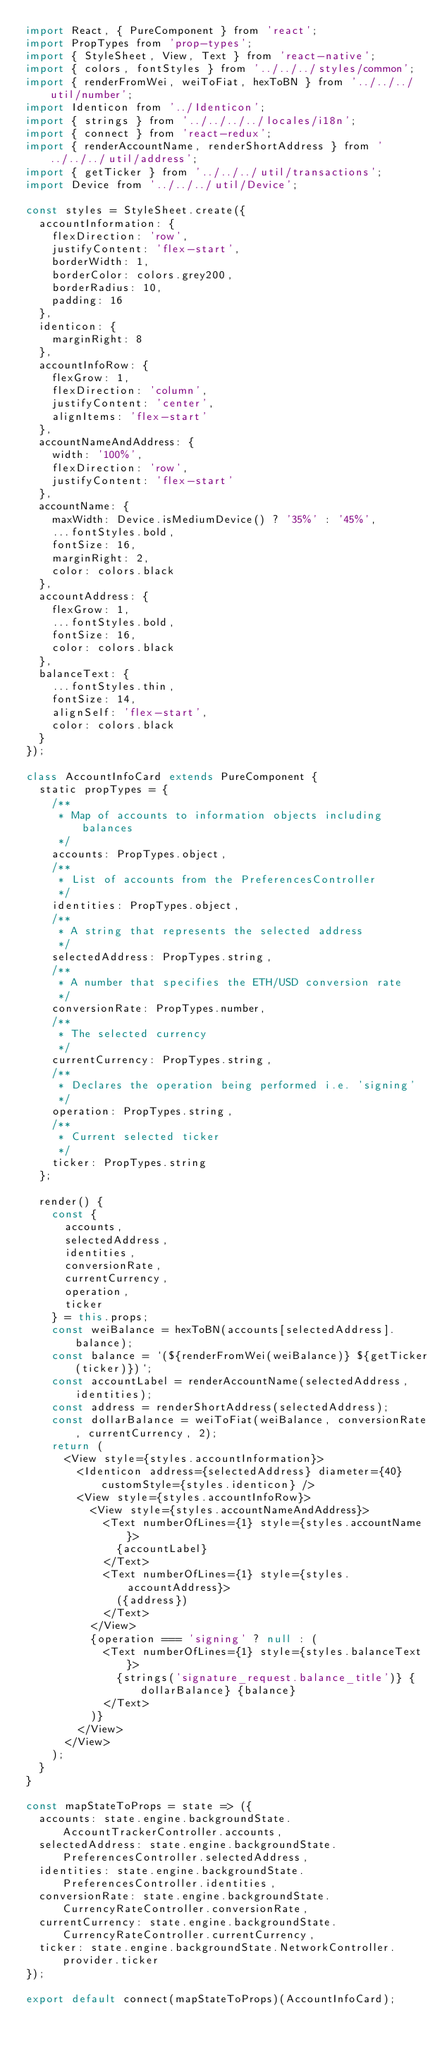<code> <loc_0><loc_0><loc_500><loc_500><_JavaScript_>import React, { PureComponent } from 'react';
import PropTypes from 'prop-types';
import { StyleSheet, View, Text } from 'react-native';
import { colors, fontStyles } from '../../../styles/common';
import { renderFromWei, weiToFiat, hexToBN } from '../../../util/number';
import Identicon from '../Identicon';
import { strings } from '../../../../locales/i18n';
import { connect } from 'react-redux';
import { renderAccountName, renderShortAddress } from '../../../util/address';
import { getTicker } from '../../../util/transactions';
import Device from '../../../util/Device';

const styles = StyleSheet.create({
	accountInformation: {
		flexDirection: 'row',
		justifyContent: 'flex-start',
		borderWidth: 1,
		borderColor: colors.grey200,
		borderRadius: 10,
		padding: 16
	},
	identicon: {
		marginRight: 8
	},
	accountInfoRow: {
		flexGrow: 1,
		flexDirection: 'column',
		justifyContent: 'center',
		alignItems: 'flex-start'
	},
	accountNameAndAddress: {
		width: '100%',
		flexDirection: 'row',
		justifyContent: 'flex-start'
	},
	accountName: {
		maxWidth: Device.isMediumDevice() ? '35%' : '45%',
		...fontStyles.bold,
		fontSize: 16,
		marginRight: 2,
		color: colors.black
	},
	accountAddress: {
		flexGrow: 1,
		...fontStyles.bold,
		fontSize: 16,
		color: colors.black
	},
	balanceText: {
		...fontStyles.thin,
		fontSize: 14,
		alignSelf: 'flex-start',
		color: colors.black
	}
});

class AccountInfoCard extends PureComponent {
	static propTypes = {
		/**
		 * Map of accounts to information objects including balances
		 */
		accounts: PropTypes.object,
		/**
		 * List of accounts from the PreferencesController
		 */
		identities: PropTypes.object,
		/**
		 * A string that represents the selected address
		 */
		selectedAddress: PropTypes.string,
		/**
		 * A number that specifies the ETH/USD conversion rate
		 */
		conversionRate: PropTypes.number,
		/**
		 * The selected currency
		 */
		currentCurrency: PropTypes.string,
		/**
		 * Declares the operation being performed i.e. 'signing'
		 */
		operation: PropTypes.string,
		/**
		 * Current selected ticker
		 */
		ticker: PropTypes.string
	};

	render() {
		const {
			accounts,
			selectedAddress,
			identities,
			conversionRate,
			currentCurrency,
			operation,
			ticker
		} = this.props;
		const weiBalance = hexToBN(accounts[selectedAddress].balance);
		const balance = `(${renderFromWei(weiBalance)} ${getTicker(ticker)})`;
		const accountLabel = renderAccountName(selectedAddress, identities);
		const address = renderShortAddress(selectedAddress);
		const dollarBalance = weiToFiat(weiBalance, conversionRate, currentCurrency, 2);
		return (
			<View style={styles.accountInformation}>
				<Identicon address={selectedAddress} diameter={40} customStyle={styles.identicon} />
				<View style={styles.accountInfoRow}>
					<View style={styles.accountNameAndAddress}>
						<Text numberOfLines={1} style={styles.accountName}>
							{accountLabel}
						</Text>
						<Text numberOfLines={1} style={styles.accountAddress}>
							({address})
						</Text>
					</View>
					{operation === 'signing' ? null : (
						<Text numberOfLines={1} style={styles.balanceText}>
							{strings('signature_request.balance_title')} {dollarBalance} {balance}
						</Text>
					)}
				</View>
			</View>
		);
	}
}

const mapStateToProps = state => ({
	accounts: state.engine.backgroundState.AccountTrackerController.accounts,
	selectedAddress: state.engine.backgroundState.PreferencesController.selectedAddress,
	identities: state.engine.backgroundState.PreferencesController.identities,
	conversionRate: state.engine.backgroundState.CurrencyRateController.conversionRate,
	currentCurrency: state.engine.backgroundState.CurrencyRateController.currentCurrency,
	ticker: state.engine.backgroundState.NetworkController.provider.ticker
});

export default connect(mapStateToProps)(AccountInfoCard);
</code> 